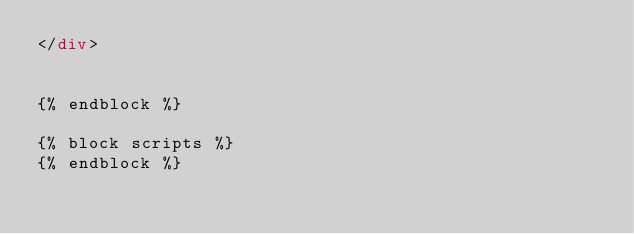<code> <loc_0><loc_0><loc_500><loc_500><_HTML_></div>


{% endblock %}

{% block scripts %}
{% endblock %}
</code> 